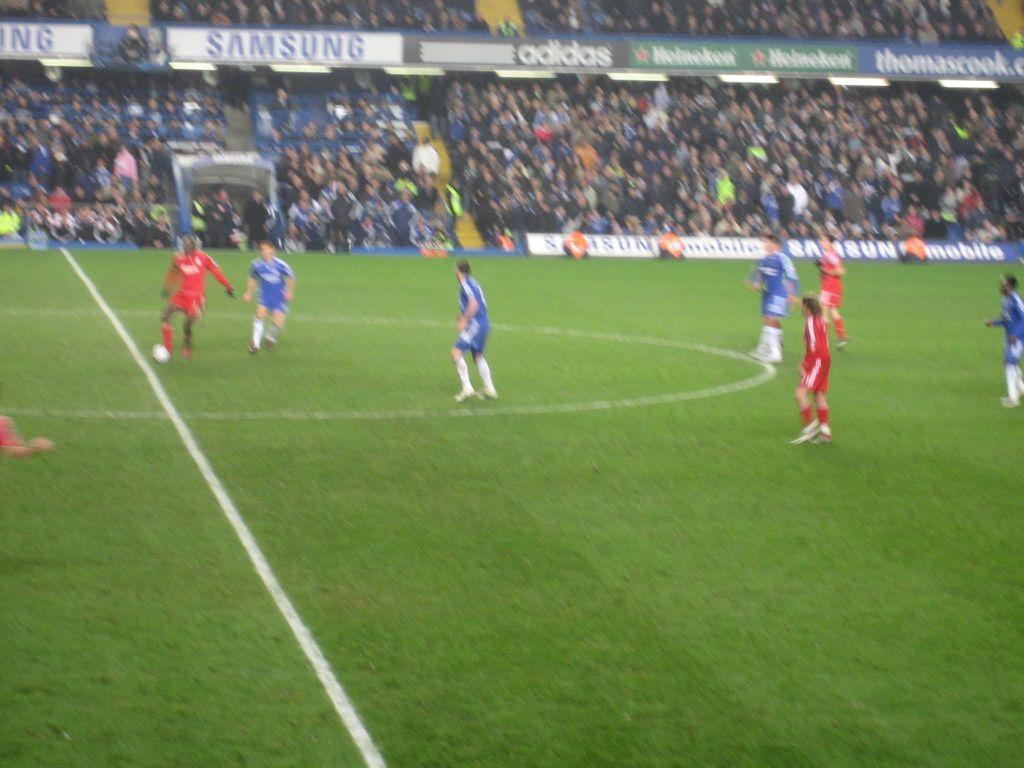<image>
Create a compact narrative representing the image presented. A red and a blue team play soccer in a stadium sponsored by Adidas, Samsung, and Heineken. 